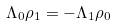<formula> <loc_0><loc_0><loc_500><loc_500>\Lambda _ { 0 } \rho _ { 1 } = - \Lambda _ { 1 } \rho _ { 0 }</formula> 